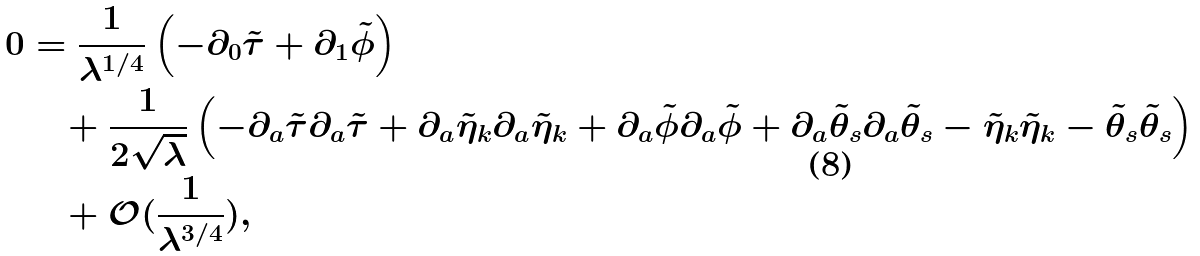Convert formula to latex. <formula><loc_0><loc_0><loc_500><loc_500>0 & = \frac { 1 } { \lambda ^ { 1 / 4 } } \left ( - \partial _ { 0 } \tilde { \tau } + \partial _ { 1 } \tilde { \phi } \right ) \\ & \quad + \frac { 1 } { 2 \sqrt { \lambda } } \left ( - \partial _ { a } \tilde { \tau } \partial _ { a } \tilde { \tau } + \partial _ { a } \tilde { \eta } _ { k } \partial _ { a } \tilde { \eta } _ { k } + \partial _ { a } \tilde { \phi } \partial _ { a } \tilde { \phi } + \partial _ { a } \tilde { \theta } _ { s } \partial _ { a } \tilde { \theta } _ { s } - \tilde { \eta } _ { k } \tilde { \eta } _ { k } - \tilde { \theta } _ { s } \tilde { \theta } _ { s } \right ) \\ & \quad + \mathcal { O } ( \frac { 1 } { \lambda ^ { 3 / 4 } } ) ,</formula> 